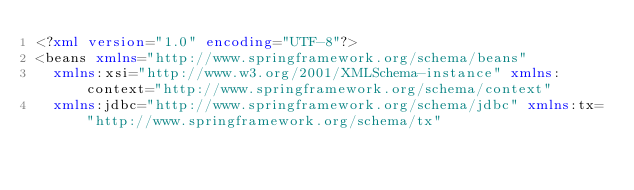Convert code to text. <code><loc_0><loc_0><loc_500><loc_500><_XML_><?xml version="1.0" encoding="UTF-8"?>
<beans xmlns="http://www.springframework.org/schema/beans"
	xmlns:xsi="http://www.w3.org/2001/XMLSchema-instance" xmlns:context="http://www.springframework.org/schema/context"
	xmlns:jdbc="http://www.springframework.org/schema/jdbc" xmlns:tx="http://www.springframework.org/schema/tx"</code> 